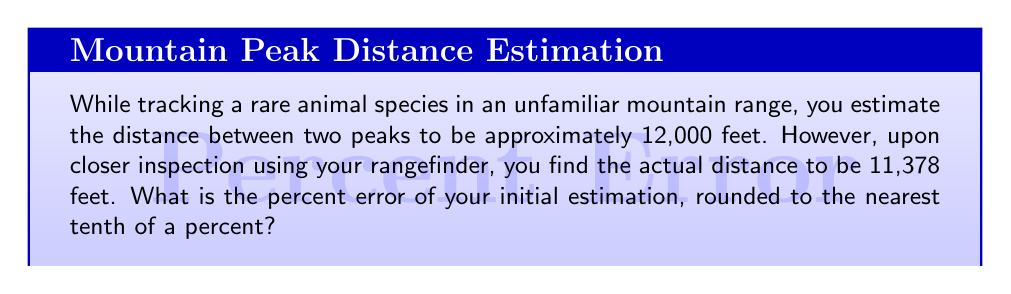Teach me how to tackle this problem. To solve this problem, we'll follow these steps:

1) First, let's recall the formula for percent error:

   $$ \text{Percent Error} = \left|\frac{\text{Estimated Value} - \text{Actual Value}}{\text{Actual Value}}\right| \times 100\% $$

2) We have:
   - Estimated Value = 12,000 feet
   - Actual Value = 11,378 feet

3) Let's substitute these values into our formula:

   $$ \text{Percent Error} = \left|\frac{12,000 - 11,378}{11,378}\right| \times 100\% $$

4) Simplify the numerator:

   $$ \text{Percent Error} = \left|\frac{622}{11,378}\right| \times 100\% $$

5) Divide:

   $$ \text{Percent Error} = 0.054667... \times 100\% $$

6) Multiply by 100 to get the percentage:

   $$ \text{Percent Error} = 5.4667...\% $$

7) Rounding to the nearest tenth of a percent:

   $$ \text{Percent Error} \approx 5.5\% $$

This calculation shows that your initial estimation was off by approximately 5.5% from the actual distance.
Answer: 5.5% 